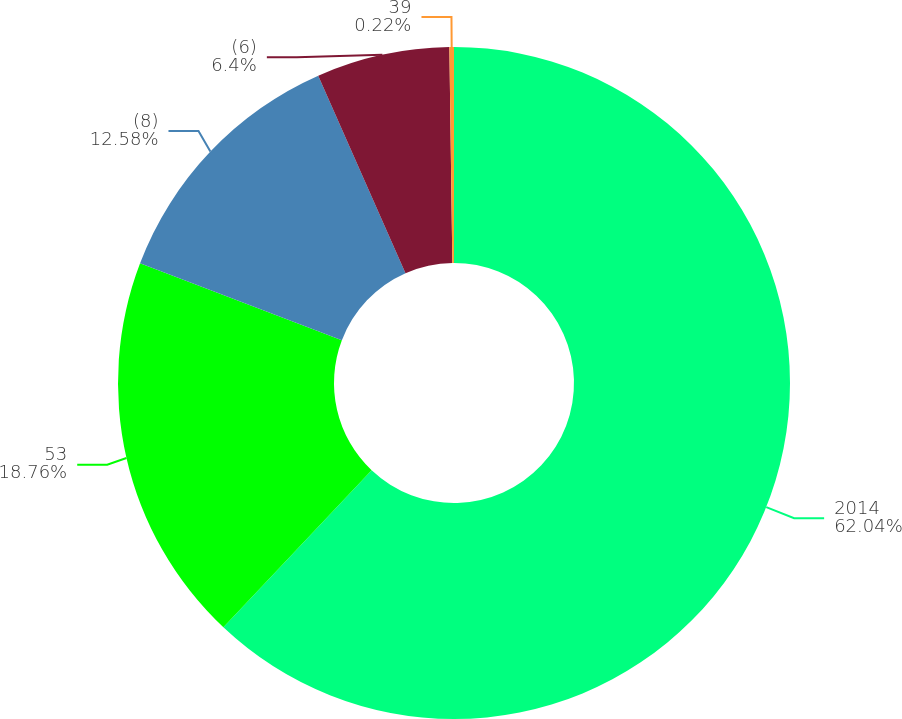<chart> <loc_0><loc_0><loc_500><loc_500><pie_chart><fcel>2014<fcel>53<fcel>(8)<fcel>(6)<fcel>39<nl><fcel>62.04%<fcel>18.76%<fcel>12.58%<fcel>6.4%<fcel>0.22%<nl></chart> 